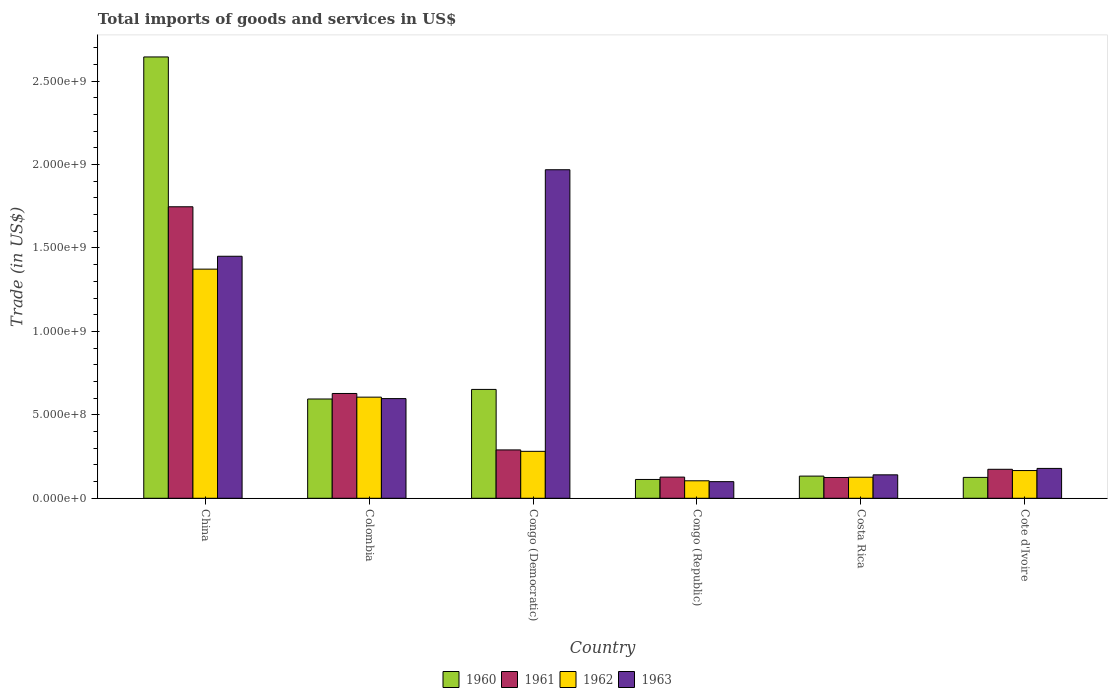How many groups of bars are there?
Make the answer very short. 6. What is the label of the 6th group of bars from the left?
Make the answer very short. Cote d'Ivoire. In how many cases, is the number of bars for a given country not equal to the number of legend labels?
Provide a short and direct response. 0. What is the total imports of goods and services in 1962 in Cote d'Ivoire?
Give a very brief answer. 1.66e+08. Across all countries, what is the maximum total imports of goods and services in 1962?
Make the answer very short. 1.37e+09. Across all countries, what is the minimum total imports of goods and services in 1963?
Give a very brief answer. 9.96e+07. In which country was the total imports of goods and services in 1963 maximum?
Keep it short and to the point. Congo (Democratic). In which country was the total imports of goods and services in 1962 minimum?
Keep it short and to the point. Congo (Republic). What is the total total imports of goods and services in 1961 in the graph?
Provide a short and direct response. 3.09e+09. What is the difference between the total imports of goods and services in 1960 in Congo (Democratic) and that in Cote d'Ivoire?
Your response must be concise. 5.27e+08. What is the difference between the total imports of goods and services in 1961 in Congo (Republic) and the total imports of goods and services in 1963 in Cote d'Ivoire?
Your answer should be very brief. -5.21e+07. What is the average total imports of goods and services in 1961 per country?
Keep it short and to the point. 5.15e+08. What is the difference between the total imports of goods and services of/in 1961 and total imports of goods and services of/in 1960 in Colombia?
Give a very brief answer. 3.30e+07. In how many countries, is the total imports of goods and services in 1963 greater than 2600000000 US$?
Your answer should be very brief. 0. What is the ratio of the total imports of goods and services in 1962 in Colombia to that in Congo (Republic)?
Your response must be concise. 5.78. Is the total imports of goods and services in 1961 in China less than that in Colombia?
Make the answer very short. No. Is the difference between the total imports of goods and services in 1961 in China and Costa Rica greater than the difference between the total imports of goods and services in 1960 in China and Costa Rica?
Your answer should be very brief. No. What is the difference between the highest and the second highest total imports of goods and services in 1961?
Provide a short and direct response. -1.46e+09. What is the difference between the highest and the lowest total imports of goods and services in 1963?
Your answer should be very brief. 1.87e+09. Is the sum of the total imports of goods and services in 1961 in Colombia and Congo (Democratic) greater than the maximum total imports of goods and services in 1963 across all countries?
Offer a very short reply. No. What does the 1st bar from the right in Congo (Republic) represents?
Make the answer very short. 1963. Is it the case that in every country, the sum of the total imports of goods and services in 1963 and total imports of goods and services in 1961 is greater than the total imports of goods and services in 1962?
Keep it short and to the point. Yes. Are all the bars in the graph horizontal?
Offer a terse response. No. How many countries are there in the graph?
Keep it short and to the point. 6. What is the difference between two consecutive major ticks on the Y-axis?
Your answer should be very brief. 5.00e+08. Are the values on the major ticks of Y-axis written in scientific E-notation?
Provide a short and direct response. Yes. How many legend labels are there?
Your answer should be very brief. 4. How are the legend labels stacked?
Your response must be concise. Horizontal. What is the title of the graph?
Your response must be concise. Total imports of goods and services in US$. Does "2005" appear as one of the legend labels in the graph?
Ensure brevity in your answer.  No. What is the label or title of the Y-axis?
Provide a short and direct response. Trade (in US$). What is the Trade (in US$) in 1960 in China?
Your response must be concise. 2.64e+09. What is the Trade (in US$) in 1961 in China?
Provide a short and direct response. 1.75e+09. What is the Trade (in US$) of 1962 in China?
Keep it short and to the point. 1.37e+09. What is the Trade (in US$) in 1963 in China?
Make the answer very short. 1.45e+09. What is the Trade (in US$) of 1960 in Colombia?
Your answer should be very brief. 5.95e+08. What is the Trade (in US$) of 1961 in Colombia?
Make the answer very short. 6.28e+08. What is the Trade (in US$) in 1962 in Colombia?
Offer a terse response. 6.06e+08. What is the Trade (in US$) of 1963 in Colombia?
Give a very brief answer. 5.97e+08. What is the Trade (in US$) of 1960 in Congo (Democratic)?
Keep it short and to the point. 6.52e+08. What is the Trade (in US$) of 1961 in Congo (Democratic)?
Offer a very short reply. 2.90e+08. What is the Trade (in US$) in 1962 in Congo (Democratic)?
Offer a very short reply. 2.81e+08. What is the Trade (in US$) of 1963 in Congo (Democratic)?
Your response must be concise. 1.97e+09. What is the Trade (in US$) of 1960 in Congo (Republic)?
Your answer should be compact. 1.13e+08. What is the Trade (in US$) of 1961 in Congo (Republic)?
Your answer should be very brief. 1.27e+08. What is the Trade (in US$) of 1962 in Congo (Republic)?
Your answer should be compact. 1.05e+08. What is the Trade (in US$) in 1963 in Congo (Republic)?
Offer a very short reply. 9.96e+07. What is the Trade (in US$) in 1960 in Costa Rica?
Keep it short and to the point. 1.33e+08. What is the Trade (in US$) in 1961 in Costa Rica?
Offer a very short reply. 1.25e+08. What is the Trade (in US$) in 1962 in Costa Rica?
Your response must be concise. 1.26e+08. What is the Trade (in US$) in 1963 in Costa Rica?
Ensure brevity in your answer.  1.40e+08. What is the Trade (in US$) of 1960 in Cote d'Ivoire?
Your answer should be compact. 1.25e+08. What is the Trade (in US$) in 1961 in Cote d'Ivoire?
Your response must be concise. 1.74e+08. What is the Trade (in US$) of 1962 in Cote d'Ivoire?
Offer a terse response. 1.66e+08. What is the Trade (in US$) of 1963 in Cote d'Ivoire?
Offer a very short reply. 1.79e+08. Across all countries, what is the maximum Trade (in US$) of 1960?
Provide a short and direct response. 2.64e+09. Across all countries, what is the maximum Trade (in US$) of 1961?
Provide a short and direct response. 1.75e+09. Across all countries, what is the maximum Trade (in US$) of 1962?
Your answer should be compact. 1.37e+09. Across all countries, what is the maximum Trade (in US$) of 1963?
Your answer should be compact. 1.97e+09. Across all countries, what is the minimum Trade (in US$) of 1960?
Ensure brevity in your answer.  1.13e+08. Across all countries, what is the minimum Trade (in US$) in 1961?
Ensure brevity in your answer.  1.25e+08. Across all countries, what is the minimum Trade (in US$) in 1962?
Offer a very short reply. 1.05e+08. Across all countries, what is the minimum Trade (in US$) of 1963?
Your response must be concise. 9.96e+07. What is the total Trade (in US$) in 1960 in the graph?
Give a very brief answer. 4.26e+09. What is the total Trade (in US$) in 1961 in the graph?
Keep it short and to the point. 3.09e+09. What is the total Trade (in US$) in 1962 in the graph?
Offer a very short reply. 2.66e+09. What is the total Trade (in US$) of 1963 in the graph?
Offer a terse response. 4.44e+09. What is the difference between the Trade (in US$) in 1960 in China and that in Colombia?
Give a very brief answer. 2.05e+09. What is the difference between the Trade (in US$) in 1961 in China and that in Colombia?
Your answer should be compact. 1.12e+09. What is the difference between the Trade (in US$) of 1962 in China and that in Colombia?
Provide a short and direct response. 7.67e+08. What is the difference between the Trade (in US$) in 1963 in China and that in Colombia?
Keep it short and to the point. 8.53e+08. What is the difference between the Trade (in US$) in 1960 in China and that in Congo (Democratic)?
Keep it short and to the point. 1.99e+09. What is the difference between the Trade (in US$) of 1961 in China and that in Congo (Democratic)?
Offer a very short reply. 1.46e+09. What is the difference between the Trade (in US$) in 1962 in China and that in Congo (Democratic)?
Your answer should be compact. 1.09e+09. What is the difference between the Trade (in US$) in 1963 in China and that in Congo (Democratic)?
Make the answer very short. -5.18e+08. What is the difference between the Trade (in US$) of 1960 in China and that in Congo (Republic)?
Provide a succinct answer. 2.53e+09. What is the difference between the Trade (in US$) in 1961 in China and that in Congo (Republic)?
Your response must be concise. 1.62e+09. What is the difference between the Trade (in US$) in 1962 in China and that in Congo (Republic)?
Keep it short and to the point. 1.27e+09. What is the difference between the Trade (in US$) in 1963 in China and that in Congo (Republic)?
Offer a terse response. 1.35e+09. What is the difference between the Trade (in US$) of 1960 in China and that in Costa Rica?
Your answer should be compact. 2.51e+09. What is the difference between the Trade (in US$) in 1961 in China and that in Costa Rica?
Your response must be concise. 1.62e+09. What is the difference between the Trade (in US$) in 1962 in China and that in Costa Rica?
Make the answer very short. 1.25e+09. What is the difference between the Trade (in US$) in 1963 in China and that in Costa Rica?
Offer a terse response. 1.31e+09. What is the difference between the Trade (in US$) in 1960 in China and that in Cote d'Ivoire?
Offer a very short reply. 2.52e+09. What is the difference between the Trade (in US$) of 1961 in China and that in Cote d'Ivoire?
Offer a very short reply. 1.57e+09. What is the difference between the Trade (in US$) of 1962 in China and that in Cote d'Ivoire?
Give a very brief answer. 1.21e+09. What is the difference between the Trade (in US$) in 1963 in China and that in Cote d'Ivoire?
Your answer should be very brief. 1.27e+09. What is the difference between the Trade (in US$) in 1960 in Colombia and that in Congo (Democratic)?
Ensure brevity in your answer.  -5.74e+07. What is the difference between the Trade (in US$) of 1961 in Colombia and that in Congo (Democratic)?
Make the answer very short. 3.38e+08. What is the difference between the Trade (in US$) of 1962 in Colombia and that in Congo (Democratic)?
Offer a terse response. 3.25e+08. What is the difference between the Trade (in US$) in 1963 in Colombia and that in Congo (Democratic)?
Provide a short and direct response. -1.37e+09. What is the difference between the Trade (in US$) of 1960 in Colombia and that in Congo (Republic)?
Your response must be concise. 4.82e+08. What is the difference between the Trade (in US$) in 1961 in Colombia and that in Congo (Republic)?
Provide a short and direct response. 5.01e+08. What is the difference between the Trade (in US$) in 1962 in Colombia and that in Congo (Republic)?
Make the answer very short. 5.01e+08. What is the difference between the Trade (in US$) in 1963 in Colombia and that in Congo (Republic)?
Your response must be concise. 4.98e+08. What is the difference between the Trade (in US$) of 1960 in Colombia and that in Costa Rica?
Provide a succinct answer. 4.62e+08. What is the difference between the Trade (in US$) in 1961 in Colombia and that in Costa Rica?
Ensure brevity in your answer.  5.03e+08. What is the difference between the Trade (in US$) of 1962 in Colombia and that in Costa Rica?
Make the answer very short. 4.80e+08. What is the difference between the Trade (in US$) of 1963 in Colombia and that in Costa Rica?
Your answer should be compact. 4.57e+08. What is the difference between the Trade (in US$) of 1960 in Colombia and that in Cote d'Ivoire?
Your answer should be very brief. 4.70e+08. What is the difference between the Trade (in US$) of 1961 in Colombia and that in Cote d'Ivoire?
Make the answer very short. 4.54e+08. What is the difference between the Trade (in US$) of 1962 in Colombia and that in Cote d'Ivoire?
Make the answer very short. 4.40e+08. What is the difference between the Trade (in US$) in 1963 in Colombia and that in Cote d'Ivoire?
Make the answer very short. 4.18e+08. What is the difference between the Trade (in US$) in 1960 in Congo (Democratic) and that in Congo (Republic)?
Your answer should be compact. 5.40e+08. What is the difference between the Trade (in US$) in 1961 in Congo (Democratic) and that in Congo (Republic)?
Provide a short and direct response. 1.63e+08. What is the difference between the Trade (in US$) in 1962 in Congo (Democratic) and that in Congo (Republic)?
Provide a short and direct response. 1.76e+08. What is the difference between the Trade (in US$) in 1963 in Congo (Democratic) and that in Congo (Republic)?
Your answer should be very brief. 1.87e+09. What is the difference between the Trade (in US$) of 1960 in Congo (Democratic) and that in Costa Rica?
Your answer should be compact. 5.19e+08. What is the difference between the Trade (in US$) of 1961 in Congo (Democratic) and that in Costa Rica?
Offer a very short reply. 1.65e+08. What is the difference between the Trade (in US$) of 1962 in Congo (Democratic) and that in Costa Rica?
Your response must be concise. 1.55e+08. What is the difference between the Trade (in US$) in 1963 in Congo (Democratic) and that in Costa Rica?
Your answer should be very brief. 1.83e+09. What is the difference between the Trade (in US$) of 1960 in Congo (Democratic) and that in Cote d'Ivoire?
Give a very brief answer. 5.27e+08. What is the difference between the Trade (in US$) in 1961 in Congo (Democratic) and that in Cote d'Ivoire?
Make the answer very short. 1.16e+08. What is the difference between the Trade (in US$) in 1962 in Congo (Democratic) and that in Cote d'Ivoire?
Your answer should be very brief. 1.15e+08. What is the difference between the Trade (in US$) of 1963 in Congo (Democratic) and that in Cote d'Ivoire?
Make the answer very short. 1.79e+09. What is the difference between the Trade (in US$) in 1960 in Congo (Republic) and that in Costa Rica?
Give a very brief answer. -2.01e+07. What is the difference between the Trade (in US$) of 1961 in Congo (Republic) and that in Costa Rica?
Your answer should be compact. 2.36e+06. What is the difference between the Trade (in US$) in 1962 in Congo (Republic) and that in Costa Rica?
Offer a very short reply. -2.14e+07. What is the difference between the Trade (in US$) in 1963 in Congo (Republic) and that in Costa Rica?
Give a very brief answer. -4.08e+07. What is the difference between the Trade (in US$) in 1960 in Congo (Republic) and that in Cote d'Ivoire?
Provide a short and direct response. -1.23e+07. What is the difference between the Trade (in US$) of 1961 in Congo (Republic) and that in Cote d'Ivoire?
Make the answer very short. -4.69e+07. What is the difference between the Trade (in US$) in 1962 in Congo (Republic) and that in Cote d'Ivoire?
Provide a succinct answer. -6.13e+07. What is the difference between the Trade (in US$) of 1963 in Congo (Republic) and that in Cote d'Ivoire?
Offer a very short reply. -7.94e+07. What is the difference between the Trade (in US$) in 1960 in Costa Rica and that in Cote d'Ivoire?
Offer a very short reply. 7.75e+06. What is the difference between the Trade (in US$) of 1961 in Costa Rica and that in Cote d'Ivoire?
Offer a terse response. -4.92e+07. What is the difference between the Trade (in US$) in 1962 in Costa Rica and that in Cote d'Ivoire?
Offer a very short reply. -3.99e+07. What is the difference between the Trade (in US$) of 1963 in Costa Rica and that in Cote d'Ivoire?
Provide a short and direct response. -3.86e+07. What is the difference between the Trade (in US$) of 1960 in China and the Trade (in US$) of 1961 in Colombia?
Provide a short and direct response. 2.02e+09. What is the difference between the Trade (in US$) of 1960 in China and the Trade (in US$) of 1962 in Colombia?
Provide a short and direct response. 2.04e+09. What is the difference between the Trade (in US$) in 1960 in China and the Trade (in US$) in 1963 in Colombia?
Offer a terse response. 2.05e+09. What is the difference between the Trade (in US$) in 1961 in China and the Trade (in US$) in 1962 in Colombia?
Offer a very short reply. 1.14e+09. What is the difference between the Trade (in US$) of 1961 in China and the Trade (in US$) of 1963 in Colombia?
Offer a terse response. 1.15e+09. What is the difference between the Trade (in US$) in 1962 in China and the Trade (in US$) in 1963 in Colombia?
Give a very brief answer. 7.76e+08. What is the difference between the Trade (in US$) of 1960 in China and the Trade (in US$) of 1961 in Congo (Democratic)?
Your answer should be very brief. 2.35e+09. What is the difference between the Trade (in US$) in 1960 in China and the Trade (in US$) in 1962 in Congo (Democratic)?
Give a very brief answer. 2.36e+09. What is the difference between the Trade (in US$) in 1960 in China and the Trade (in US$) in 1963 in Congo (Democratic)?
Ensure brevity in your answer.  6.76e+08. What is the difference between the Trade (in US$) of 1961 in China and the Trade (in US$) of 1962 in Congo (Democratic)?
Offer a very short reply. 1.47e+09. What is the difference between the Trade (in US$) of 1961 in China and the Trade (in US$) of 1963 in Congo (Democratic)?
Give a very brief answer. -2.22e+08. What is the difference between the Trade (in US$) of 1962 in China and the Trade (in US$) of 1963 in Congo (Democratic)?
Provide a short and direct response. -5.96e+08. What is the difference between the Trade (in US$) in 1960 in China and the Trade (in US$) in 1961 in Congo (Republic)?
Keep it short and to the point. 2.52e+09. What is the difference between the Trade (in US$) in 1960 in China and the Trade (in US$) in 1962 in Congo (Republic)?
Your response must be concise. 2.54e+09. What is the difference between the Trade (in US$) in 1960 in China and the Trade (in US$) in 1963 in Congo (Republic)?
Offer a terse response. 2.54e+09. What is the difference between the Trade (in US$) in 1961 in China and the Trade (in US$) in 1962 in Congo (Republic)?
Provide a short and direct response. 1.64e+09. What is the difference between the Trade (in US$) in 1961 in China and the Trade (in US$) in 1963 in Congo (Republic)?
Provide a succinct answer. 1.65e+09. What is the difference between the Trade (in US$) of 1962 in China and the Trade (in US$) of 1963 in Congo (Republic)?
Give a very brief answer. 1.27e+09. What is the difference between the Trade (in US$) in 1960 in China and the Trade (in US$) in 1961 in Costa Rica?
Ensure brevity in your answer.  2.52e+09. What is the difference between the Trade (in US$) of 1960 in China and the Trade (in US$) of 1962 in Costa Rica?
Offer a terse response. 2.52e+09. What is the difference between the Trade (in US$) in 1960 in China and the Trade (in US$) in 1963 in Costa Rica?
Your answer should be compact. 2.50e+09. What is the difference between the Trade (in US$) of 1961 in China and the Trade (in US$) of 1962 in Costa Rica?
Your answer should be very brief. 1.62e+09. What is the difference between the Trade (in US$) in 1961 in China and the Trade (in US$) in 1963 in Costa Rica?
Your response must be concise. 1.61e+09. What is the difference between the Trade (in US$) of 1962 in China and the Trade (in US$) of 1963 in Costa Rica?
Your answer should be compact. 1.23e+09. What is the difference between the Trade (in US$) in 1960 in China and the Trade (in US$) in 1961 in Cote d'Ivoire?
Offer a very short reply. 2.47e+09. What is the difference between the Trade (in US$) in 1960 in China and the Trade (in US$) in 1962 in Cote d'Ivoire?
Give a very brief answer. 2.48e+09. What is the difference between the Trade (in US$) in 1960 in China and the Trade (in US$) in 1963 in Cote d'Ivoire?
Provide a short and direct response. 2.47e+09. What is the difference between the Trade (in US$) of 1961 in China and the Trade (in US$) of 1962 in Cote d'Ivoire?
Ensure brevity in your answer.  1.58e+09. What is the difference between the Trade (in US$) of 1961 in China and the Trade (in US$) of 1963 in Cote d'Ivoire?
Your answer should be very brief. 1.57e+09. What is the difference between the Trade (in US$) of 1962 in China and the Trade (in US$) of 1963 in Cote d'Ivoire?
Provide a succinct answer. 1.19e+09. What is the difference between the Trade (in US$) of 1960 in Colombia and the Trade (in US$) of 1961 in Congo (Democratic)?
Give a very brief answer. 3.05e+08. What is the difference between the Trade (in US$) in 1960 in Colombia and the Trade (in US$) in 1962 in Congo (Democratic)?
Your response must be concise. 3.14e+08. What is the difference between the Trade (in US$) of 1960 in Colombia and the Trade (in US$) of 1963 in Congo (Democratic)?
Keep it short and to the point. -1.37e+09. What is the difference between the Trade (in US$) in 1961 in Colombia and the Trade (in US$) in 1962 in Congo (Democratic)?
Your answer should be compact. 3.47e+08. What is the difference between the Trade (in US$) in 1961 in Colombia and the Trade (in US$) in 1963 in Congo (Democratic)?
Offer a terse response. -1.34e+09. What is the difference between the Trade (in US$) in 1962 in Colombia and the Trade (in US$) in 1963 in Congo (Democratic)?
Provide a short and direct response. -1.36e+09. What is the difference between the Trade (in US$) in 1960 in Colombia and the Trade (in US$) in 1961 in Congo (Republic)?
Your answer should be very brief. 4.68e+08. What is the difference between the Trade (in US$) in 1960 in Colombia and the Trade (in US$) in 1962 in Congo (Republic)?
Provide a succinct answer. 4.90e+08. What is the difference between the Trade (in US$) of 1960 in Colombia and the Trade (in US$) of 1963 in Congo (Republic)?
Your answer should be compact. 4.95e+08. What is the difference between the Trade (in US$) in 1961 in Colombia and the Trade (in US$) in 1962 in Congo (Republic)?
Keep it short and to the point. 5.23e+08. What is the difference between the Trade (in US$) of 1961 in Colombia and the Trade (in US$) of 1963 in Congo (Republic)?
Your answer should be very brief. 5.28e+08. What is the difference between the Trade (in US$) of 1962 in Colombia and the Trade (in US$) of 1963 in Congo (Republic)?
Offer a very short reply. 5.06e+08. What is the difference between the Trade (in US$) in 1960 in Colombia and the Trade (in US$) in 1961 in Costa Rica?
Offer a terse response. 4.70e+08. What is the difference between the Trade (in US$) in 1960 in Colombia and the Trade (in US$) in 1962 in Costa Rica?
Provide a short and direct response. 4.69e+08. What is the difference between the Trade (in US$) in 1960 in Colombia and the Trade (in US$) in 1963 in Costa Rica?
Offer a very short reply. 4.54e+08. What is the difference between the Trade (in US$) of 1961 in Colombia and the Trade (in US$) of 1962 in Costa Rica?
Give a very brief answer. 5.02e+08. What is the difference between the Trade (in US$) of 1961 in Colombia and the Trade (in US$) of 1963 in Costa Rica?
Your answer should be very brief. 4.88e+08. What is the difference between the Trade (in US$) of 1962 in Colombia and the Trade (in US$) of 1963 in Costa Rica?
Keep it short and to the point. 4.65e+08. What is the difference between the Trade (in US$) in 1960 in Colombia and the Trade (in US$) in 1961 in Cote d'Ivoire?
Keep it short and to the point. 4.21e+08. What is the difference between the Trade (in US$) of 1960 in Colombia and the Trade (in US$) of 1962 in Cote d'Ivoire?
Your response must be concise. 4.29e+08. What is the difference between the Trade (in US$) of 1960 in Colombia and the Trade (in US$) of 1963 in Cote d'Ivoire?
Your response must be concise. 4.16e+08. What is the difference between the Trade (in US$) of 1961 in Colombia and the Trade (in US$) of 1962 in Cote d'Ivoire?
Keep it short and to the point. 4.62e+08. What is the difference between the Trade (in US$) of 1961 in Colombia and the Trade (in US$) of 1963 in Cote d'Ivoire?
Make the answer very short. 4.49e+08. What is the difference between the Trade (in US$) in 1962 in Colombia and the Trade (in US$) in 1963 in Cote d'Ivoire?
Give a very brief answer. 4.27e+08. What is the difference between the Trade (in US$) in 1960 in Congo (Democratic) and the Trade (in US$) in 1961 in Congo (Republic)?
Keep it short and to the point. 5.25e+08. What is the difference between the Trade (in US$) of 1960 in Congo (Democratic) and the Trade (in US$) of 1962 in Congo (Republic)?
Offer a terse response. 5.47e+08. What is the difference between the Trade (in US$) in 1960 in Congo (Democratic) and the Trade (in US$) in 1963 in Congo (Republic)?
Offer a terse response. 5.53e+08. What is the difference between the Trade (in US$) in 1961 in Congo (Democratic) and the Trade (in US$) in 1962 in Congo (Republic)?
Give a very brief answer. 1.85e+08. What is the difference between the Trade (in US$) in 1961 in Congo (Democratic) and the Trade (in US$) in 1963 in Congo (Republic)?
Your answer should be very brief. 1.90e+08. What is the difference between the Trade (in US$) in 1962 in Congo (Democratic) and the Trade (in US$) in 1963 in Congo (Republic)?
Provide a succinct answer. 1.82e+08. What is the difference between the Trade (in US$) of 1960 in Congo (Democratic) and the Trade (in US$) of 1961 in Costa Rica?
Offer a very short reply. 5.28e+08. What is the difference between the Trade (in US$) of 1960 in Congo (Democratic) and the Trade (in US$) of 1962 in Costa Rica?
Your answer should be very brief. 5.26e+08. What is the difference between the Trade (in US$) of 1960 in Congo (Democratic) and the Trade (in US$) of 1963 in Costa Rica?
Your response must be concise. 5.12e+08. What is the difference between the Trade (in US$) in 1961 in Congo (Democratic) and the Trade (in US$) in 1962 in Costa Rica?
Give a very brief answer. 1.64e+08. What is the difference between the Trade (in US$) in 1961 in Congo (Democratic) and the Trade (in US$) in 1963 in Costa Rica?
Offer a terse response. 1.49e+08. What is the difference between the Trade (in US$) of 1962 in Congo (Democratic) and the Trade (in US$) of 1963 in Costa Rica?
Provide a short and direct response. 1.41e+08. What is the difference between the Trade (in US$) of 1960 in Congo (Democratic) and the Trade (in US$) of 1961 in Cote d'Ivoire?
Give a very brief answer. 4.79e+08. What is the difference between the Trade (in US$) in 1960 in Congo (Democratic) and the Trade (in US$) in 1962 in Cote d'Ivoire?
Offer a terse response. 4.86e+08. What is the difference between the Trade (in US$) in 1960 in Congo (Democratic) and the Trade (in US$) in 1963 in Cote d'Ivoire?
Keep it short and to the point. 4.73e+08. What is the difference between the Trade (in US$) of 1961 in Congo (Democratic) and the Trade (in US$) of 1962 in Cote d'Ivoire?
Offer a very short reply. 1.24e+08. What is the difference between the Trade (in US$) of 1961 in Congo (Democratic) and the Trade (in US$) of 1963 in Cote d'Ivoire?
Give a very brief answer. 1.11e+08. What is the difference between the Trade (in US$) of 1962 in Congo (Democratic) and the Trade (in US$) of 1963 in Cote d'Ivoire?
Ensure brevity in your answer.  1.02e+08. What is the difference between the Trade (in US$) in 1960 in Congo (Republic) and the Trade (in US$) in 1961 in Costa Rica?
Provide a short and direct response. -1.18e+07. What is the difference between the Trade (in US$) in 1960 in Congo (Republic) and the Trade (in US$) in 1962 in Costa Rica?
Offer a very short reply. -1.35e+07. What is the difference between the Trade (in US$) in 1960 in Congo (Republic) and the Trade (in US$) in 1963 in Costa Rica?
Your answer should be compact. -2.77e+07. What is the difference between the Trade (in US$) in 1961 in Congo (Republic) and the Trade (in US$) in 1962 in Costa Rica?
Provide a succinct answer. 6.55e+05. What is the difference between the Trade (in US$) of 1961 in Congo (Republic) and the Trade (in US$) of 1963 in Costa Rica?
Your response must be concise. -1.35e+07. What is the difference between the Trade (in US$) of 1962 in Congo (Republic) and the Trade (in US$) of 1963 in Costa Rica?
Ensure brevity in your answer.  -3.56e+07. What is the difference between the Trade (in US$) of 1960 in Congo (Republic) and the Trade (in US$) of 1961 in Cote d'Ivoire?
Your response must be concise. -6.10e+07. What is the difference between the Trade (in US$) of 1960 in Congo (Republic) and the Trade (in US$) of 1962 in Cote d'Ivoire?
Offer a terse response. -5.34e+07. What is the difference between the Trade (in US$) in 1960 in Congo (Republic) and the Trade (in US$) in 1963 in Cote d'Ivoire?
Make the answer very short. -6.62e+07. What is the difference between the Trade (in US$) in 1961 in Congo (Republic) and the Trade (in US$) in 1962 in Cote d'Ivoire?
Make the answer very short. -3.92e+07. What is the difference between the Trade (in US$) in 1961 in Congo (Republic) and the Trade (in US$) in 1963 in Cote d'Ivoire?
Provide a short and direct response. -5.21e+07. What is the difference between the Trade (in US$) in 1962 in Congo (Republic) and the Trade (in US$) in 1963 in Cote d'Ivoire?
Ensure brevity in your answer.  -7.42e+07. What is the difference between the Trade (in US$) of 1960 in Costa Rica and the Trade (in US$) of 1961 in Cote d'Ivoire?
Your answer should be very brief. -4.09e+07. What is the difference between the Trade (in US$) of 1960 in Costa Rica and the Trade (in US$) of 1962 in Cote d'Ivoire?
Ensure brevity in your answer.  -3.33e+07. What is the difference between the Trade (in US$) in 1960 in Costa Rica and the Trade (in US$) in 1963 in Cote d'Ivoire?
Your response must be concise. -4.61e+07. What is the difference between the Trade (in US$) in 1961 in Costa Rica and the Trade (in US$) in 1962 in Cote d'Ivoire?
Offer a very short reply. -4.16e+07. What is the difference between the Trade (in US$) in 1961 in Costa Rica and the Trade (in US$) in 1963 in Cote d'Ivoire?
Your answer should be very brief. -5.45e+07. What is the difference between the Trade (in US$) of 1962 in Costa Rica and the Trade (in US$) of 1963 in Cote d'Ivoire?
Keep it short and to the point. -5.28e+07. What is the average Trade (in US$) of 1960 per country?
Your response must be concise. 7.10e+08. What is the average Trade (in US$) in 1961 per country?
Your answer should be very brief. 5.15e+08. What is the average Trade (in US$) in 1962 per country?
Provide a succinct answer. 4.43e+08. What is the average Trade (in US$) of 1963 per country?
Ensure brevity in your answer.  7.39e+08. What is the difference between the Trade (in US$) of 1960 and Trade (in US$) of 1961 in China?
Offer a very short reply. 8.98e+08. What is the difference between the Trade (in US$) in 1960 and Trade (in US$) in 1962 in China?
Your response must be concise. 1.27e+09. What is the difference between the Trade (in US$) of 1960 and Trade (in US$) of 1963 in China?
Keep it short and to the point. 1.19e+09. What is the difference between the Trade (in US$) of 1961 and Trade (in US$) of 1962 in China?
Provide a succinct answer. 3.74e+08. What is the difference between the Trade (in US$) of 1961 and Trade (in US$) of 1963 in China?
Ensure brevity in your answer.  2.97e+08. What is the difference between the Trade (in US$) in 1962 and Trade (in US$) in 1963 in China?
Ensure brevity in your answer.  -7.72e+07. What is the difference between the Trade (in US$) in 1960 and Trade (in US$) in 1961 in Colombia?
Make the answer very short. -3.30e+07. What is the difference between the Trade (in US$) of 1960 and Trade (in US$) of 1962 in Colombia?
Your response must be concise. -1.10e+07. What is the difference between the Trade (in US$) of 1960 and Trade (in US$) of 1963 in Colombia?
Ensure brevity in your answer.  -2.39e+06. What is the difference between the Trade (in US$) of 1961 and Trade (in US$) of 1962 in Colombia?
Give a very brief answer. 2.20e+07. What is the difference between the Trade (in US$) in 1961 and Trade (in US$) in 1963 in Colombia?
Your answer should be very brief. 3.06e+07. What is the difference between the Trade (in US$) in 1962 and Trade (in US$) in 1963 in Colombia?
Give a very brief answer. 8.64e+06. What is the difference between the Trade (in US$) of 1960 and Trade (in US$) of 1961 in Congo (Democratic)?
Provide a short and direct response. 3.63e+08. What is the difference between the Trade (in US$) in 1960 and Trade (in US$) in 1962 in Congo (Democratic)?
Ensure brevity in your answer.  3.71e+08. What is the difference between the Trade (in US$) of 1960 and Trade (in US$) of 1963 in Congo (Democratic)?
Your response must be concise. -1.32e+09. What is the difference between the Trade (in US$) of 1961 and Trade (in US$) of 1962 in Congo (Democratic)?
Offer a very short reply. 8.49e+06. What is the difference between the Trade (in US$) of 1961 and Trade (in US$) of 1963 in Congo (Democratic)?
Your answer should be very brief. -1.68e+09. What is the difference between the Trade (in US$) in 1962 and Trade (in US$) in 1963 in Congo (Democratic)?
Your answer should be compact. -1.69e+09. What is the difference between the Trade (in US$) of 1960 and Trade (in US$) of 1961 in Congo (Republic)?
Your answer should be very brief. -1.41e+07. What is the difference between the Trade (in US$) in 1960 and Trade (in US$) in 1962 in Congo (Republic)?
Your response must be concise. 7.94e+06. What is the difference between the Trade (in US$) in 1960 and Trade (in US$) in 1963 in Congo (Republic)?
Your answer should be compact. 1.31e+07. What is the difference between the Trade (in US$) in 1961 and Trade (in US$) in 1962 in Congo (Republic)?
Keep it short and to the point. 2.21e+07. What is the difference between the Trade (in US$) in 1961 and Trade (in US$) in 1963 in Congo (Republic)?
Keep it short and to the point. 2.73e+07. What is the difference between the Trade (in US$) in 1962 and Trade (in US$) in 1963 in Congo (Republic)?
Ensure brevity in your answer.  5.20e+06. What is the difference between the Trade (in US$) in 1960 and Trade (in US$) in 1961 in Costa Rica?
Offer a terse response. 8.32e+06. What is the difference between the Trade (in US$) in 1960 and Trade (in US$) in 1962 in Costa Rica?
Give a very brief answer. 6.62e+06. What is the difference between the Trade (in US$) in 1960 and Trade (in US$) in 1963 in Costa Rica?
Keep it short and to the point. -7.58e+06. What is the difference between the Trade (in US$) of 1961 and Trade (in US$) of 1962 in Costa Rica?
Ensure brevity in your answer.  -1.70e+06. What is the difference between the Trade (in US$) of 1961 and Trade (in US$) of 1963 in Costa Rica?
Provide a succinct answer. -1.59e+07. What is the difference between the Trade (in US$) of 1962 and Trade (in US$) of 1963 in Costa Rica?
Make the answer very short. -1.42e+07. What is the difference between the Trade (in US$) in 1960 and Trade (in US$) in 1961 in Cote d'Ivoire?
Offer a terse response. -4.86e+07. What is the difference between the Trade (in US$) of 1960 and Trade (in US$) of 1962 in Cote d'Ivoire?
Provide a short and direct response. -4.10e+07. What is the difference between the Trade (in US$) of 1960 and Trade (in US$) of 1963 in Cote d'Ivoire?
Make the answer very short. -5.39e+07. What is the difference between the Trade (in US$) of 1961 and Trade (in US$) of 1962 in Cote d'Ivoire?
Keep it short and to the point. 7.61e+06. What is the difference between the Trade (in US$) of 1961 and Trade (in US$) of 1963 in Cote d'Ivoire?
Provide a succinct answer. -5.25e+06. What is the difference between the Trade (in US$) in 1962 and Trade (in US$) in 1963 in Cote d'Ivoire?
Offer a terse response. -1.29e+07. What is the ratio of the Trade (in US$) of 1960 in China to that in Colombia?
Your answer should be compact. 4.45. What is the ratio of the Trade (in US$) of 1961 in China to that in Colombia?
Provide a short and direct response. 2.78. What is the ratio of the Trade (in US$) of 1962 in China to that in Colombia?
Ensure brevity in your answer.  2.27. What is the ratio of the Trade (in US$) in 1963 in China to that in Colombia?
Offer a very short reply. 2.43. What is the ratio of the Trade (in US$) of 1960 in China to that in Congo (Democratic)?
Keep it short and to the point. 4.05. What is the ratio of the Trade (in US$) of 1961 in China to that in Congo (Democratic)?
Keep it short and to the point. 6.03. What is the ratio of the Trade (in US$) in 1962 in China to that in Congo (Democratic)?
Your response must be concise. 4.88. What is the ratio of the Trade (in US$) of 1963 in China to that in Congo (Democratic)?
Ensure brevity in your answer.  0.74. What is the ratio of the Trade (in US$) of 1960 in China to that in Congo (Republic)?
Keep it short and to the point. 23.45. What is the ratio of the Trade (in US$) in 1961 in China to that in Congo (Republic)?
Provide a short and direct response. 13.76. What is the ratio of the Trade (in US$) in 1962 in China to that in Congo (Republic)?
Keep it short and to the point. 13.1. What is the ratio of the Trade (in US$) in 1963 in China to that in Congo (Republic)?
Your response must be concise. 14.55. What is the ratio of the Trade (in US$) of 1960 in China to that in Costa Rica?
Provide a succinct answer. 19.9. What is the ratio of the Trade (in US$) in 1961 in China to that in Costa Rica?
Provide a short and direct response. 14.03. What is the ratio of the Trade (in US$) of 1962 in China to that in Costa Rica?
Offer a terse response. 10.88. What is the ratio of the Trade (in US$) in 1963 in China to that in Costa Rica?
Provide a succinct answer. 10.33. What is the ratio of the Trade (in US$) in 1960 in China to that in Cote d'Ivoire?
Ensure brevity in your answer.  21.14. What is the ratio of the Trade (in US$) of 1961 in China to that in Cote d'Ivoire?
Give a very brief answer. 10.05. What is the ratio of the Trade (in US$) in 1962 in China to that in Cote d'Ivoire?
Provide a short and direct response. 8.26. What is the ratio of the Trade (in US$) in 1963 in China to that in Cote d'Ivoire?
Your answer should be compact. 8.1. What is the ratio of the Trade (in US$) in 1960 in Colombia to that in Congo (Democratic)?
Make the answer very short. 0.91. What is the ratio of the Trade (in US$) of 1961 in Colombia to that in Congo (Democratic)?
Keep it short and to the point. 2.17. What is the ratio of the Trade (in US$) of 1962 in Colombia to that in Congo (Democratic)?
Ensure brevity in your answer.  2.15. What is the ratio of the Trade (in US$) of 1963 in Colombia to that in Congo (Democratic)?
Offer a very short reply. 0.3. What is the ratio of the Trade (in US$) of 1960 in Colombia to that in Congo (Republic)?
Offer a very short reply. 5.28. What is the ratio of the Trade (in US$) in 1961 in Colombia to that in Congo (Republic)?
Make the answer very short. 4.95. What is the ratio of the Trade (in US$) of 1962 in Colombia to that in Congo (Republic)?
Keep it short and to the point. 5.78. What is the ratio of the Trade (in US$) of 1963 in Colombia to that in Congo (Republic)?
Ensure brevity in your answer.  5.99. What is the ratio of the Trade (in US$) in 1960 in Colombia to that in Costa Rica?
Give a very brief answer. 4.48. What is the ratio of the Trade (in US$) of 1961 in Colombia to that in Costa Rica?
Your answer should be very brief. 5.04. What is the ratio of the Trade (in US$) in 1962 in Colombia to that in Costa Rica?
Provide a short and direct response. 4.8. What is the ratio of the Trade (in US$) in 1963 in Colombia to that in Costa Rica?
Give a very brief answer. 4.25. What is the ratio of the Trade (in US$) of 1960 in Colombia to that in Cote d'Ivoire?
Offer a terse response. 4.76. What is the ratio of the Trade (in US$) in 1961 in Colombia to that in Cote d'Ivoire?
Keep it short and to the point. 3.61. What is the ratio of the Trade (in US$) of 1962 in Colombia to that in Cote d'Ivoire?
Provide a short and direct response. 3.65. What is the ratio of the Trade (in US$) of 1963 in Colombia to that in Cote d'Ivoire?
Make the answer very short. 3.34. What is the ratio of the Trade (in US$) in 1960 in Congo (Democratic) to that in Congo (Republic)?
Your response must be concise. 5.78. What is the ratio of the Trade (in US$) in 1961 in Congo (Democratic) to that in Congo (Republic)?
Give a very brief answer. 2.28. What is the ratio of the Trade (in US$) in 1962 in Congo (Democratic) to that in Congo (Republic)?
Ensure brevity in your answer.  2.68. What is the ratio of the Trade (in US$) of 1963 in Congo (Democratic) to that in Congo (Republic)?
Ensure brevity in your answer.  19.76. What is the ratio of the Trade (in US$) in 1960 in Congo (Democratic) to that in Costa Rica?
Keep it short and to the point. 4.91. What is the ratio of the Trade (in US$) in 1961 in Congo (Democratic) to that in Costa Rica?
Give a very brief answer. 2.33. What is the ratio of the Trade (in US$) of 1962 in Congo (Democratic) to that in Costa Rica?
Offer a very short reply. 2.23. What is the ratio of the Trade (in US$) in 1963 in Congo (Democratic) to that in Costa Rica?
Provide a succinct answer. 14.02. What is the ratio of the Trade (in US$) of 1960 in Congo (Democratic) to that in Cote d'Ivoire?
Offer a very short reply. 5.21. What is the ratio of the Trade (in US$) of 1961 in Congo (Democratic) to that in Cote d'Ivoire?
Make the answer very short. 1.67. What is the ratio of the Trade (in US$) in 1962 in Congo (Democratic) to that in Cote d'Ivoire?
Your answer should be compact. 1.69. What is the ratio of the Trade (in US$) of 1963 in Congo (Democratic) to that in Cote d'Ivoire?
Ensure brevity in your answer.  11. What is the ratio of the Trade (in US$) in 1960 in Congo (Republic) to that in Costa Rica?
Provide a short and direct response. 0.85. What is the ratio of the Trade (in US$) of 1961 in Congo (Republic) to that in Costa Rica?
Your response must be concise. 1.02. What is the ratio of the Trade (in US$) in 1962 in Congo (Republic) to that in Costa Rica?
Ensure brevity in your answer.  0.83. What is the ratio of the Trade (in US$) of 1963 in Congo (Republic) to that in Costa Rica?
Give a very brief answer. 0.71. What is the ratio of the Trade (in US$) of 1960 in Congo (Republic) to that in Cote d'Ivoire?
Provide a short and direct response. 0.9. What is the ratio of the Trade (in US$) in 1961 in Congo (Republic) to that in Cote d'Ivoire?
Ensure brevity in your answer.  0.73. What is the ratio of the Trade (in US$) of 1962 in Congo (Republic) to that in Cote d'Ivoire?
Keep it short and to the point. 0.63. What is the ratio of the Trade (in US$) of 1963 in Congo (Republic) to that in Cote d'Ivoire?
Your answer should be very brief. 0.56. What is the ratio of the Trade (in US$) in 1960 in Costa Rica to that in Cote d'Ivoire?
Provide a succinct answer. 1.06. What is the ratio of the Trade (in US$) of 1961 in Costa Rica to that in Cote d'Ivoire?
Provide a short and direct response. 0.72. What is the ratio of the Trade (in US$) of 1962 in Costa Rica to that in Cote d'Ivoire?
Ensure brevity in your answer.  0.76. What is the ratio of the Trade (in US$) in 1963 in Costa Rica to that in Cote d'Ivoire?
Give a very brief answer. 0.78. What is the difference between the highest and the second highest Trade (in US$) of 1960?
Provide a succinct answer. 1.99e+09. What is the difference between the highest and the second highest Trade (in US$) of 1961?
Give a very brief answer. 1.12e+09. What is the difference between the highest and the second highest Trade (in US$) in 1962?
Keep it short and to the point. 7.67e+08. What is the difference between the highest and the second highest Trade (in US$) of 1963?
Provide a short and direct response. 5.18e+08. What is the difference between the highest and the lowest Trade (in US$) of 1960?
Give a very brief answer. 2.53e+09. What is the difference between the highest and the lowest Trade (in US$) of 1961?
Your answer should be very brief. 1.62e+09. What is the difference between the highest and the lowest Trade (in US$) of 1962?
Make the answer very short. 1.27e+09. What is the difference between the highest and the lowest Trade (in US$) of 1963?
Give a very brief answer. 1.87e+09. 